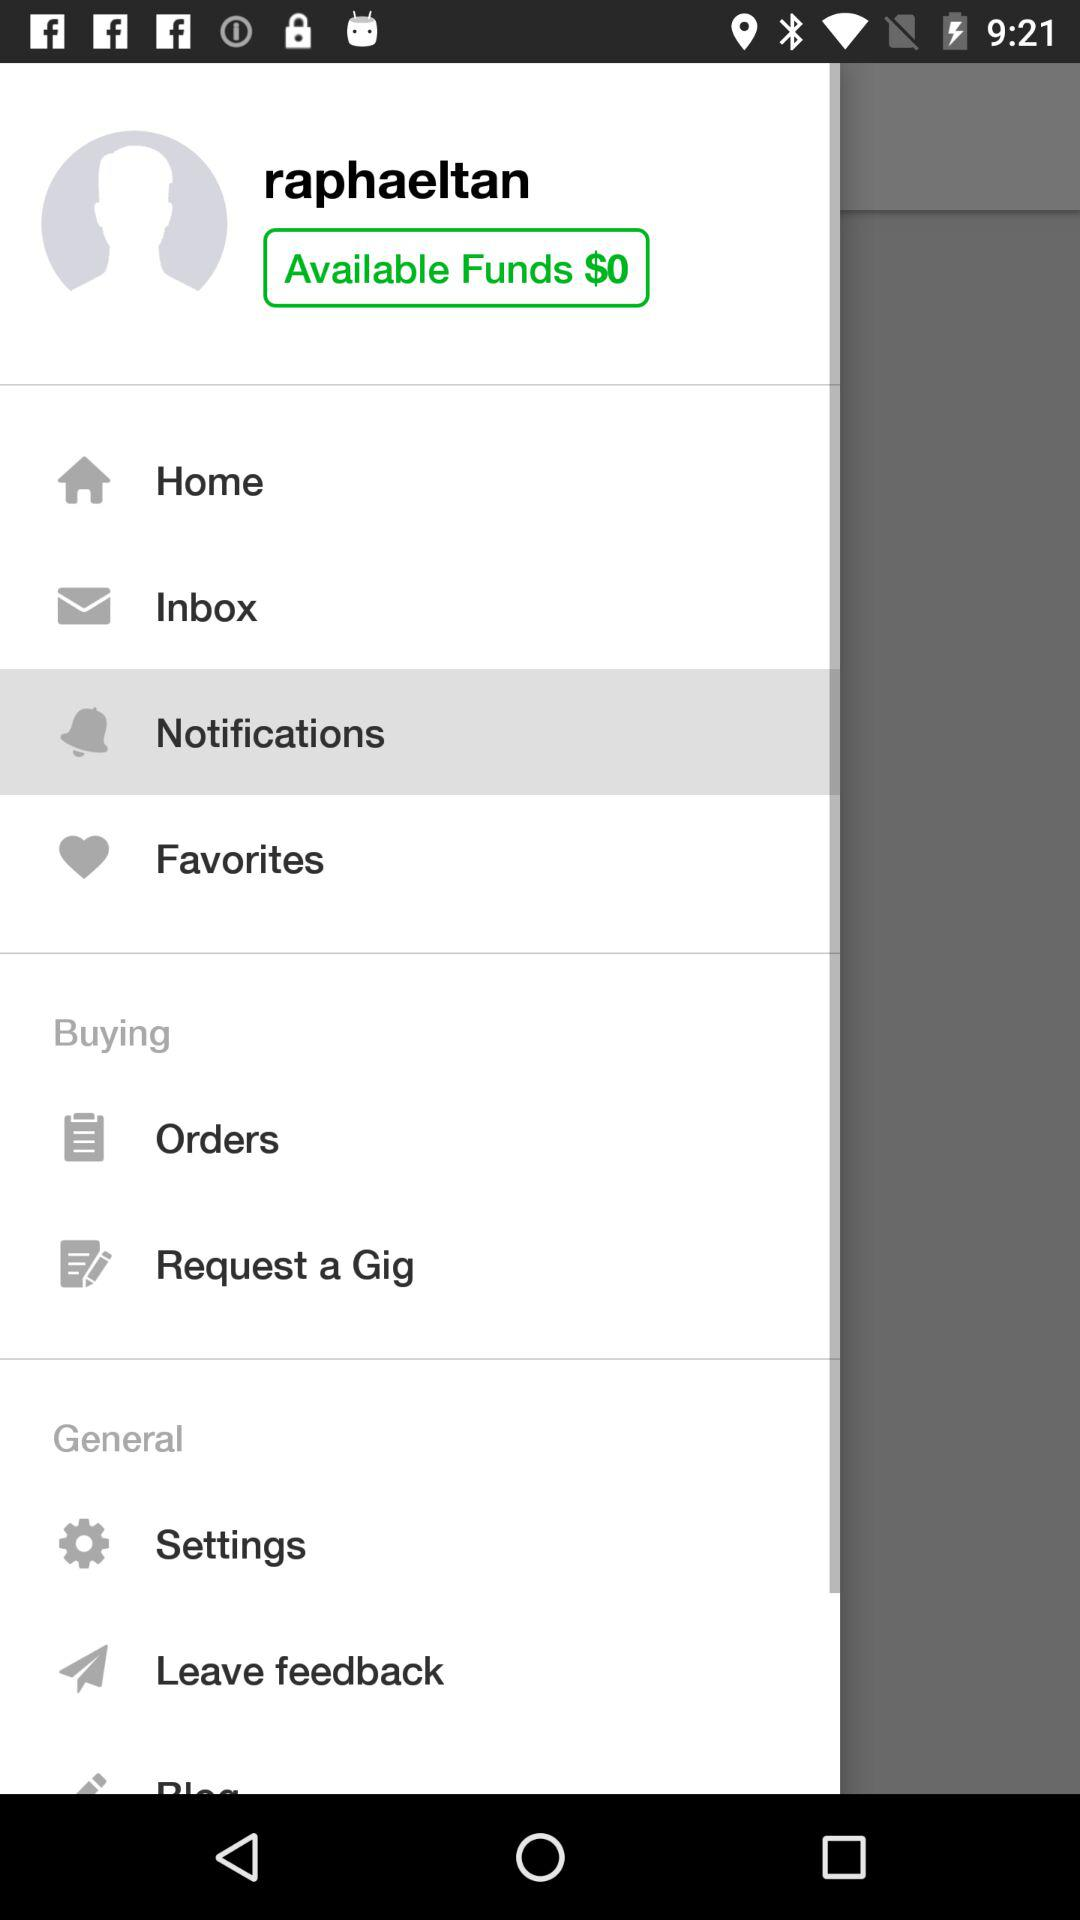What's the available fund? The available fund is $0. 